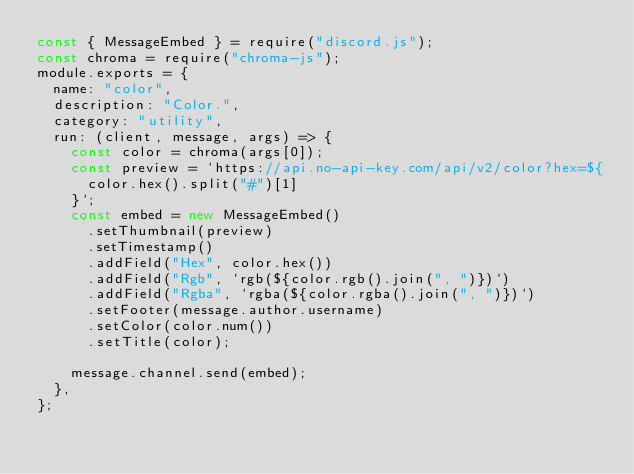<code> <loc_0><loc_0><loc_500><loc_500><_JavaScript_>const { MessageEmbed } = require("discord.js");
const chroma = require("chroma-js");
module.exports = {
  name: "color",
  description: "Color.",
  category: "utility",
  run: (client, message, args) => {
    const color = chroma(args[0]);
    const preview = `https://api.no-api-key.com/api/v2/color?hex=${
      color.hex().split("#")[1]
    }`;
    const embed = new MessageEmbed()
      .setThumbnail(preview)
      .setTimestamp()
      .addField("Hex", color.hex())
      .addField("Rgb", `rgb(${color.rgb().join(", ")})`)
      .addField("Rgba", `rgba(${color.rgba().join(", ")})`)
      .setFooter(message.author.username)
      .setColor(color.num())
      .setTitle(color);

    message.channel.send(embed);
  },
};
</code> 